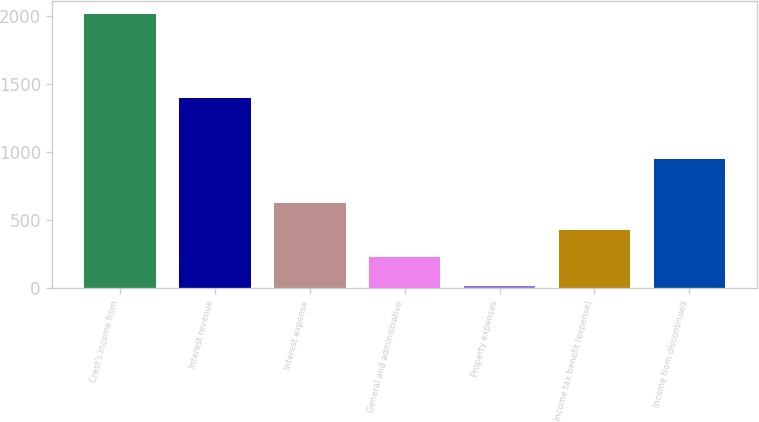Convert chart. <chart><loc_0><loc_0><loc_500><loc_500><bar_chart><fcel>Crest's income from<fcel>Interest revenue<fcel>Interest expense<fcel>General and administrative<fcel>Property expenses<fcel>Income tax benefit (expense)<fcel>Income from discontinued<nl><fcel>2010<fcel>1397<fcel>625.6<fcel>226<fcel>12<fcel>425.8<fcel>946<nl></chart> 